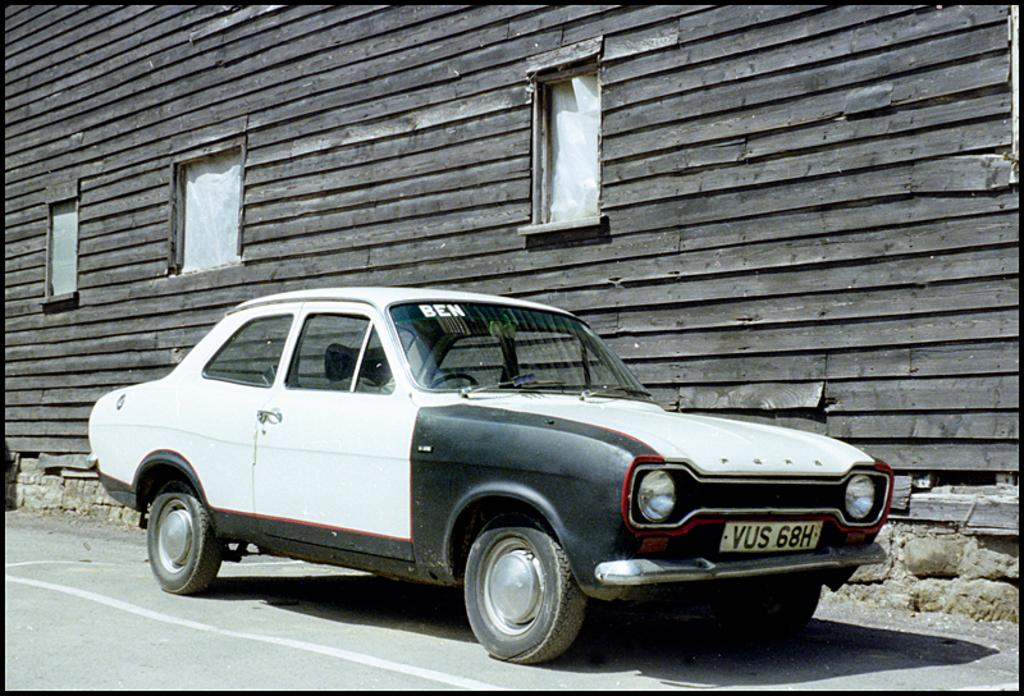What is the main subject of the image? The main subject of the image is a car on the road. What is located near the car? There is a wall with windows near the car. What type of material can be seen in the image? Bricks are visible in the image. What type of tramp is performing in front of the car in the image? There is no tramp performing in front of the car in the image. What authority figure is present in the image? There is no authority figure present in the image. 